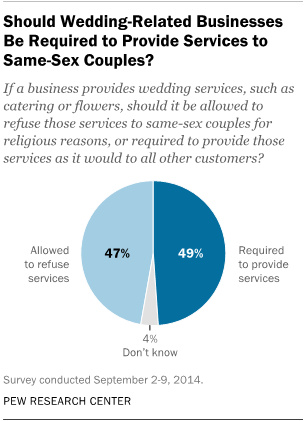Indicate a few pertinent items in this graphic. The smallest segment of the graph is colored gray. In total, the value of services that a person is allowed to refuse and the services that they are required to provide adds up to 96. 